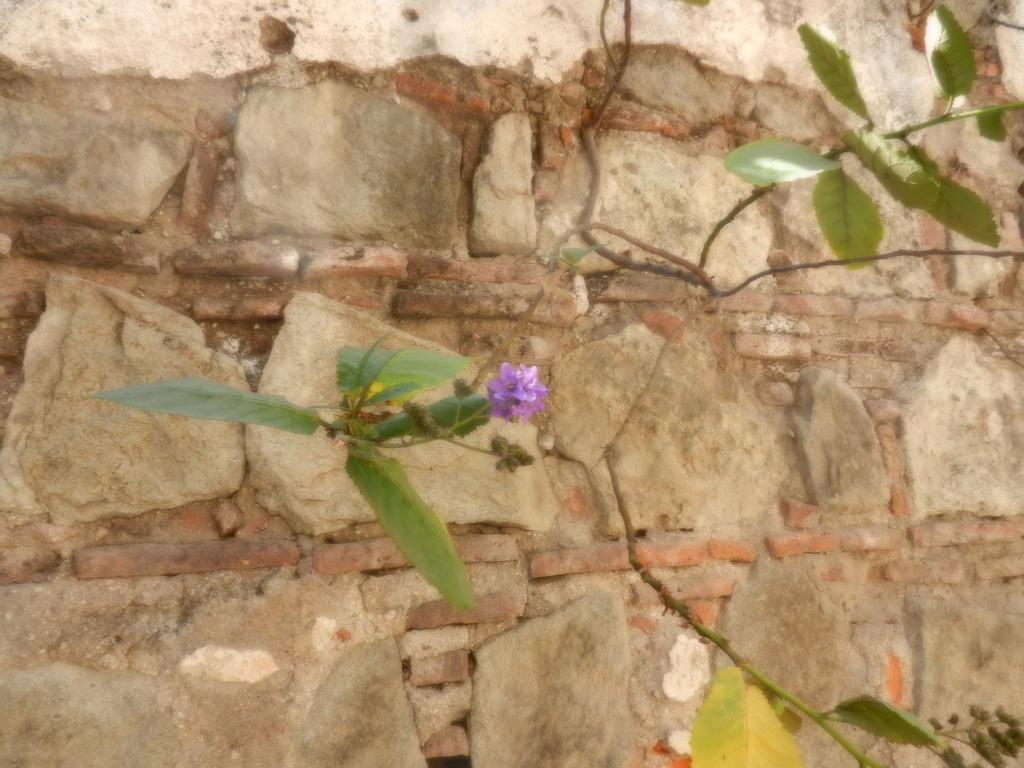Can you describe this image briefly? In this image I can see few green colour leaves and a purple colour flower over here. I can also see the wall in the background. 